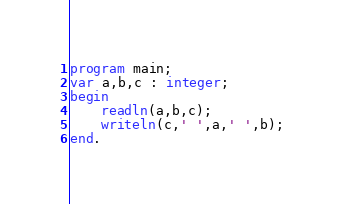<code> <loc_0><loc_0><loc_500><loc_500><_Pascal_>program main;
var a,b,c : integer;
begin
	readln(a,b,c);
    writeln(c,' ',a,' ',b);
end.</code> 